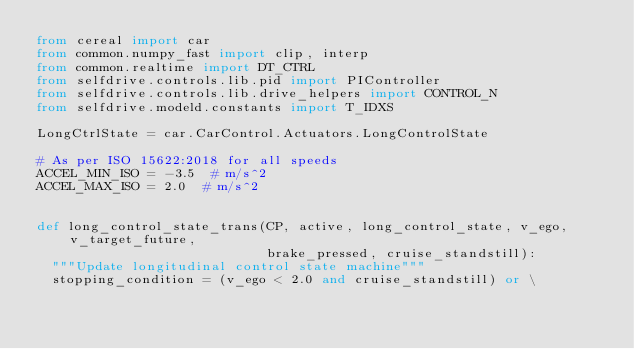<code> <loc_0><loc_0><loc_500><loc_500><_Python_>from cereal import car
from common.numpy_fast import clip, interp
from common.realtime import DT_CTRL
from selfdrive.controls.lib.pid import PIController
from selfdrive.controls.lib.drive_helpers import CONTROL_N
from selfdrive.modeld.constants import T_IDXS

LongCtrlState = car.CarControl.Actuators.LongControlState

# As per ISO 15622:2018 for all speeds
ACCEL_MIN_ISO = -3.5  # m/s^2
ACCEL_MAX_ISO = 2.0  # m/s^2


def long_control_state_trans(CP, active, long_control_state, v_ego, v_target_future,
                             brake_pressed, cruise_standstill):
  """Update longitudinal control state machine"""
  stopping_condition = (v_ego < 2.0 and cruise_standstill) or \</code> 